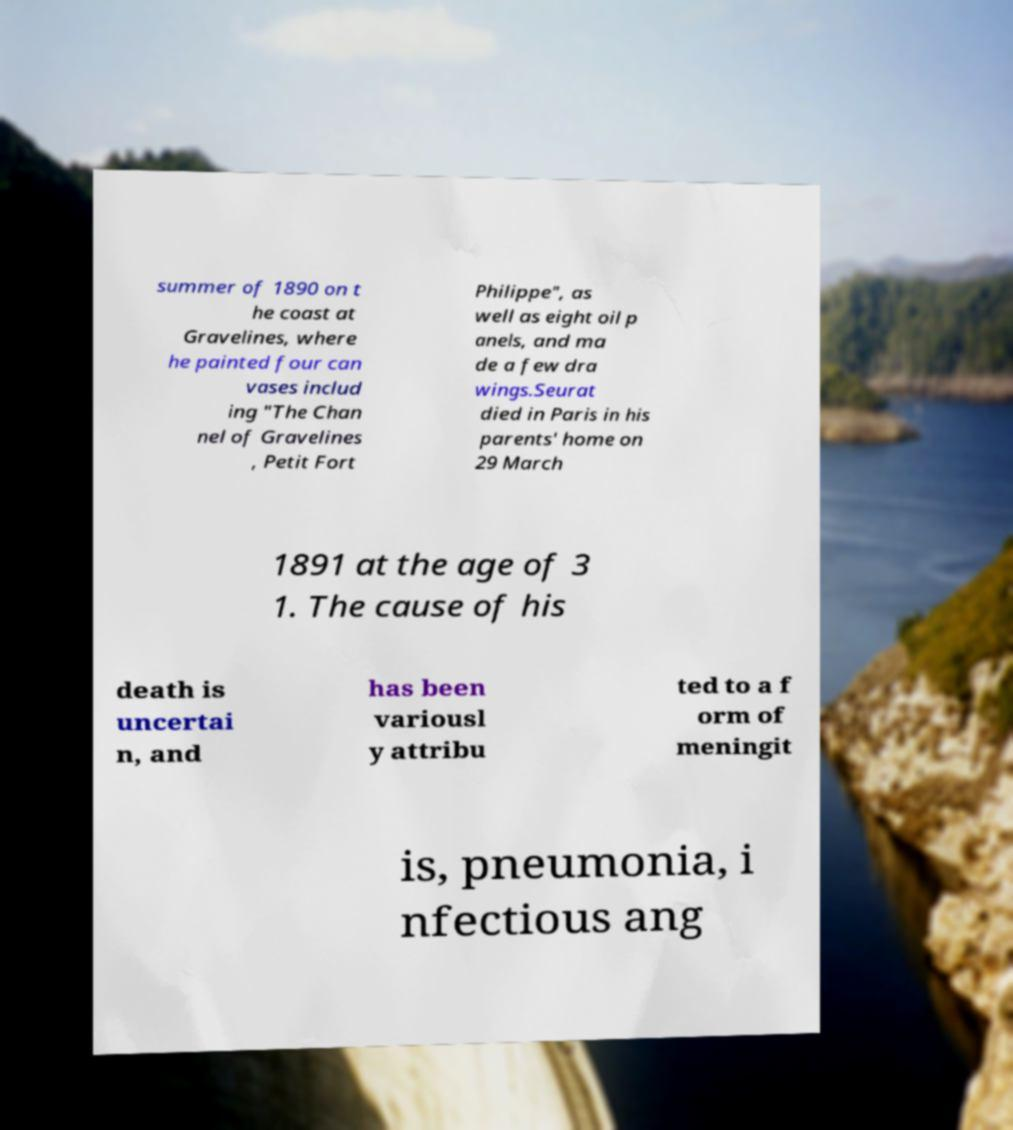I need the written content from this picture converted into text. Can you do that? summer of 1890 on t he coast at Gravelines, where he painted four can vases includ ing "The Chan nel of Gravelines , Petit Fort Philippe", as well as eight oil p anels, and ma de a few dra wings.Seurat died in Paris in his parents' home on 29 March 1891 at the age of 3 1. The cause of his death is uncertai n, and has been variousl y attribu ted to a f orm of meningit is, pneumonia, i nfectious ang 